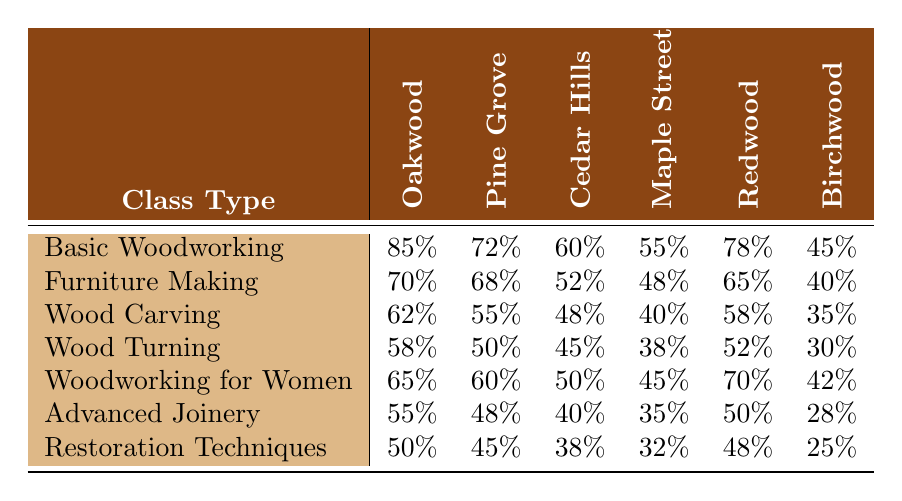What is the attendance rate for Basic Woodworking at the Oakwood Community Center? The table shows the attendance rates for each class type at various community centers. For Basic Woodworking, the attendance rate at Oakwood Community Center is 85%.
Answer: 85% What is the lowest attendance rate for any class at the Birchwood Arts Complex? The table shows all attendance rates for classes at Birchwood Arts Complex. The lowest rate listed is 25% for Restoration Techniques.
Answer: 25% Which class has the highest attendance rate at the Cedar Hills Workshop? Looking at the attendance for Cedar Hills Workshop across all classes, Basic Woodworking has the highest rate at 60%.
Answer: 60% Is the attendance rate for Wood Turning at Pine Grove Rec Center higher than that for Wood Carving? The table lists the attendance rates: Wood Turning at Pine Grove is 50% and Wood Carving is 55%. Since 50% is less than 55%, the statement is false.
Answer: No What is the average attendance rate for Furniture Making across all community centers? To find the average, add the attendance rates for Furniture Making at each center: 70% + 68% + 52% + 48% + 65% + 40% = 343%. Then divide by 6 (the number of centers): 343% / 6 ≈ 57.17%.
Answer: 57.17% How many community centers have an attendance rate above 60% for Woodworking for Women? The attendance rates for Woodworking for Women are 65%, 60%, 50%, 45%, 70%, and 42%. The rates above 60% are at Oakwood (65%) and Redwood (70%). So, there are 2 centers.
Answer: 2 What class has the largest difference in attendance rates between the highest and lowest community centers? Looking at each class type, calculate the difference between the highest and lowest rates: for Woodworking for Women, 70% (Redwood) - 42% (Birchwood) = 28%. Other classes have smaller differences. The largest is for Woodworking for Women.
Answer: Woodworking for Women What is the total attendance rate for Advanced Joinery across all community centers? The attendance rates for Advanced Joinery at each center are: 55%, 48%, 40%, 35%, 50%, and 28%. Adding these together: 55 + 48 + 40 + 35 + 50 + 28 = 256%.
Answer: 256% Which class type at Maple Street Learning Hub has an attendance rate below 40%? Checking the attendance rates at Maple Street, Wood Turning has a rate of 38%, which is below 40%.
Answer: Yes Are there any classes at Redwood Senior Center with attendance rates below 30%? The table shows attendance rates for Redwood Senior Center: 78%, 65%, 58%, 52%, 70%, and 42%. None of these rates are below 30%.
Answer: No 